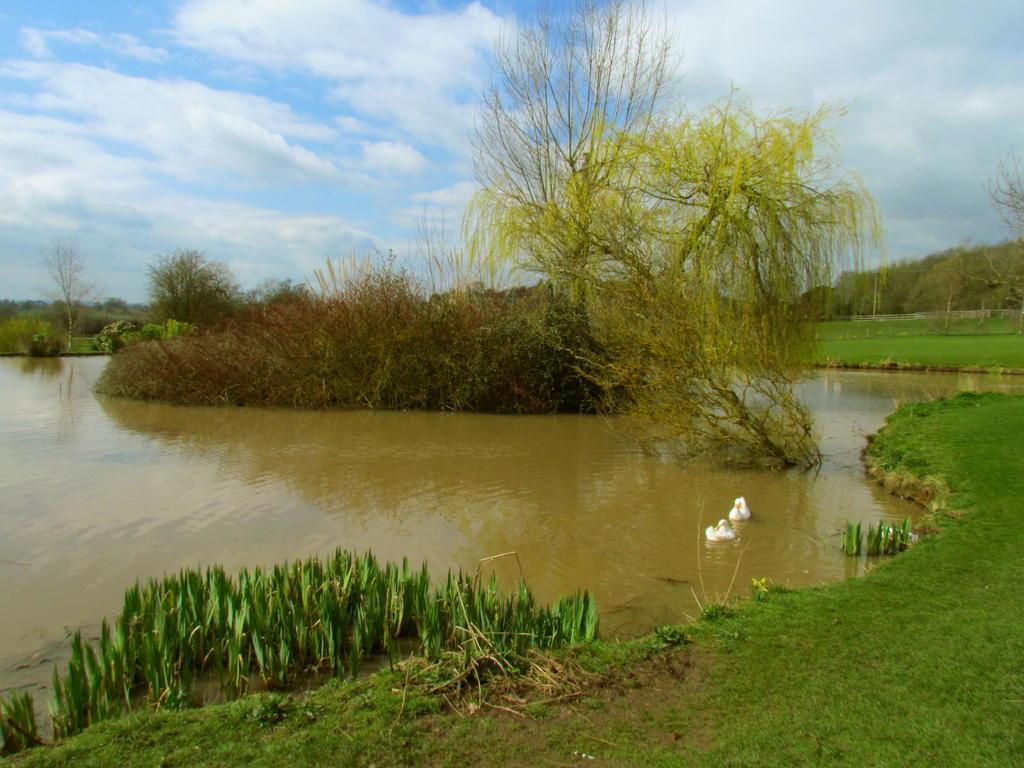Describe this image in one or two sentences. In the picture we can see a small canal with water and around it we can see a grass surface and in the water we can see some plants and in the background we can see some trees and sky with clouds. 